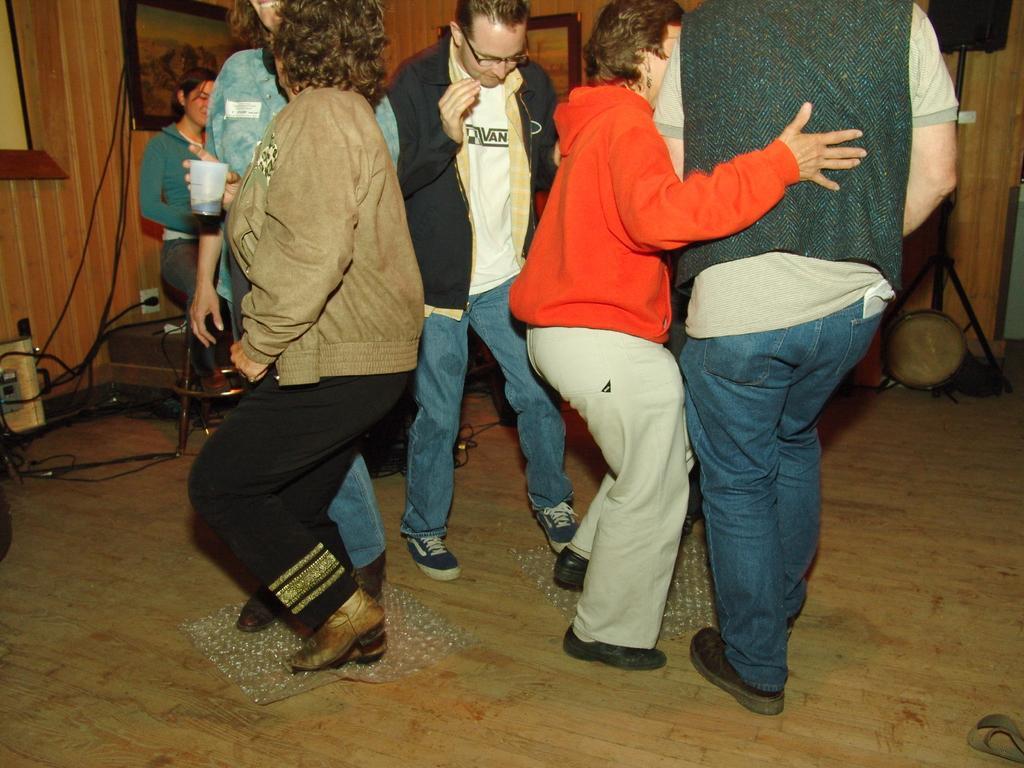In one or two sentences, can you explain what this image depicts? Here we can see few persons. This is floor. In the background we can see frames, stand, speaker, cables, and wall. 